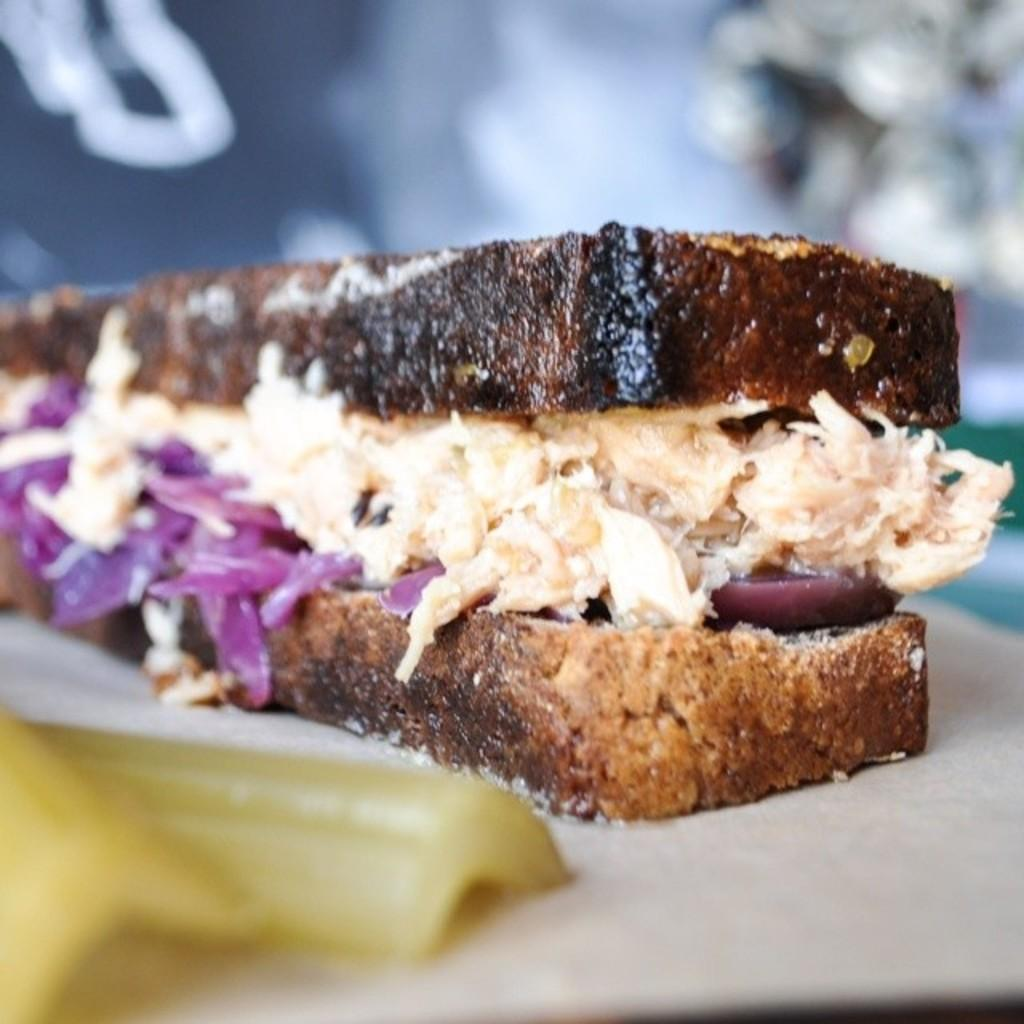What is the main food item in the center of the image? There is a sandwich on a plate in the center of the image. What type of vegetable can be seen on the left side of the image? There is a vegetable on the left side of the image. Can you describe the background of the image? The background of the image is blurred. What type of cap is the ant wearing in the image? There is no ant or cap present in the image. Can you recall any memories that the image might evoke? The image does not evoke any specific memories, as it only contains a sandwich, a vegetable, and a blurred background. 